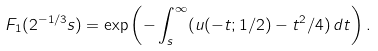Convert formula to latex. <formula><loc_0><loc_0><loc_500><loc_500>F _ { 1 } ( 2 ^ { - 1 / 3 } s ) = \exp \left ( - \int _ { s } ^ { \infty } ( u ( - t ; 1 / 2 ) - t ^ { 2 } / 4 ) \, d t \right ) .</formula> 